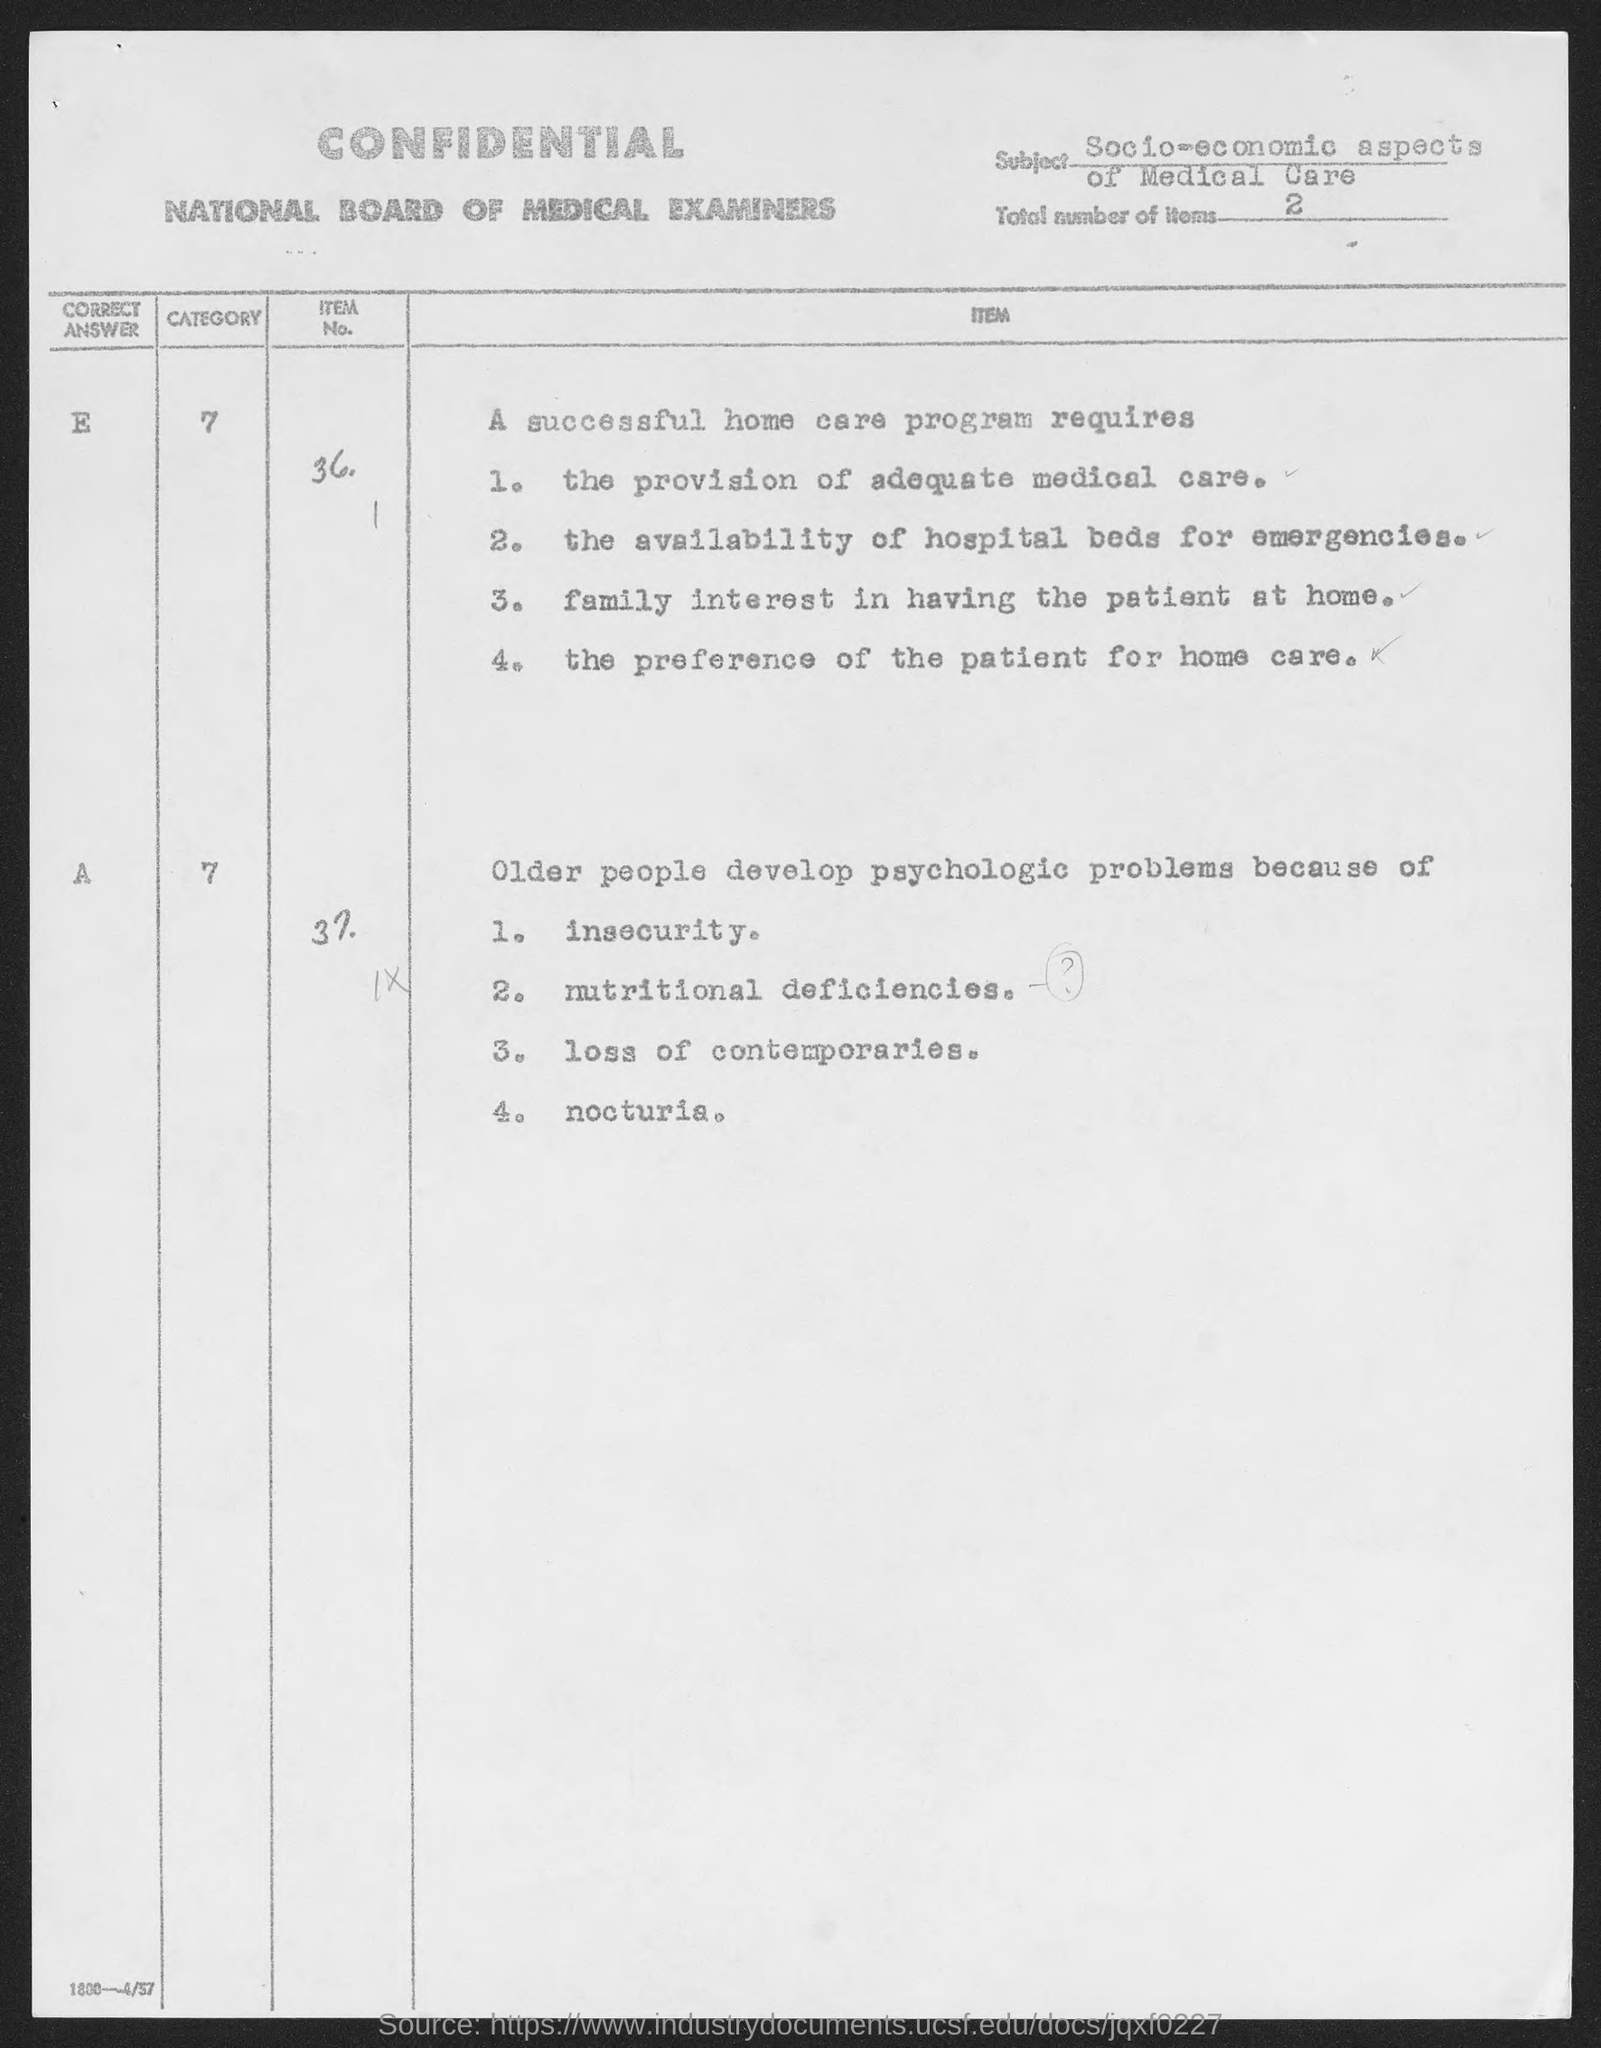What is the total number of items given in the document?
Offer a terse response. 2. 